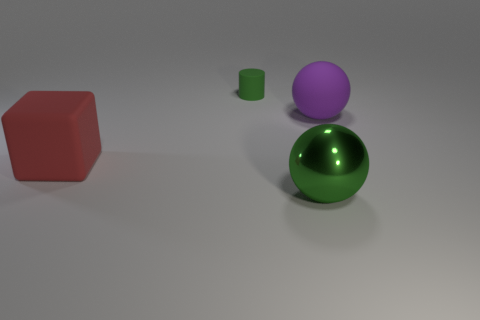There is a matte object that is in front of the big ball that is to the right of the green object in front of the green rubber cylinder; what is its size? The matte object in front of the large green sphere to the right of the smaller green cylinder is of medium size compared to the other objects in the image. 